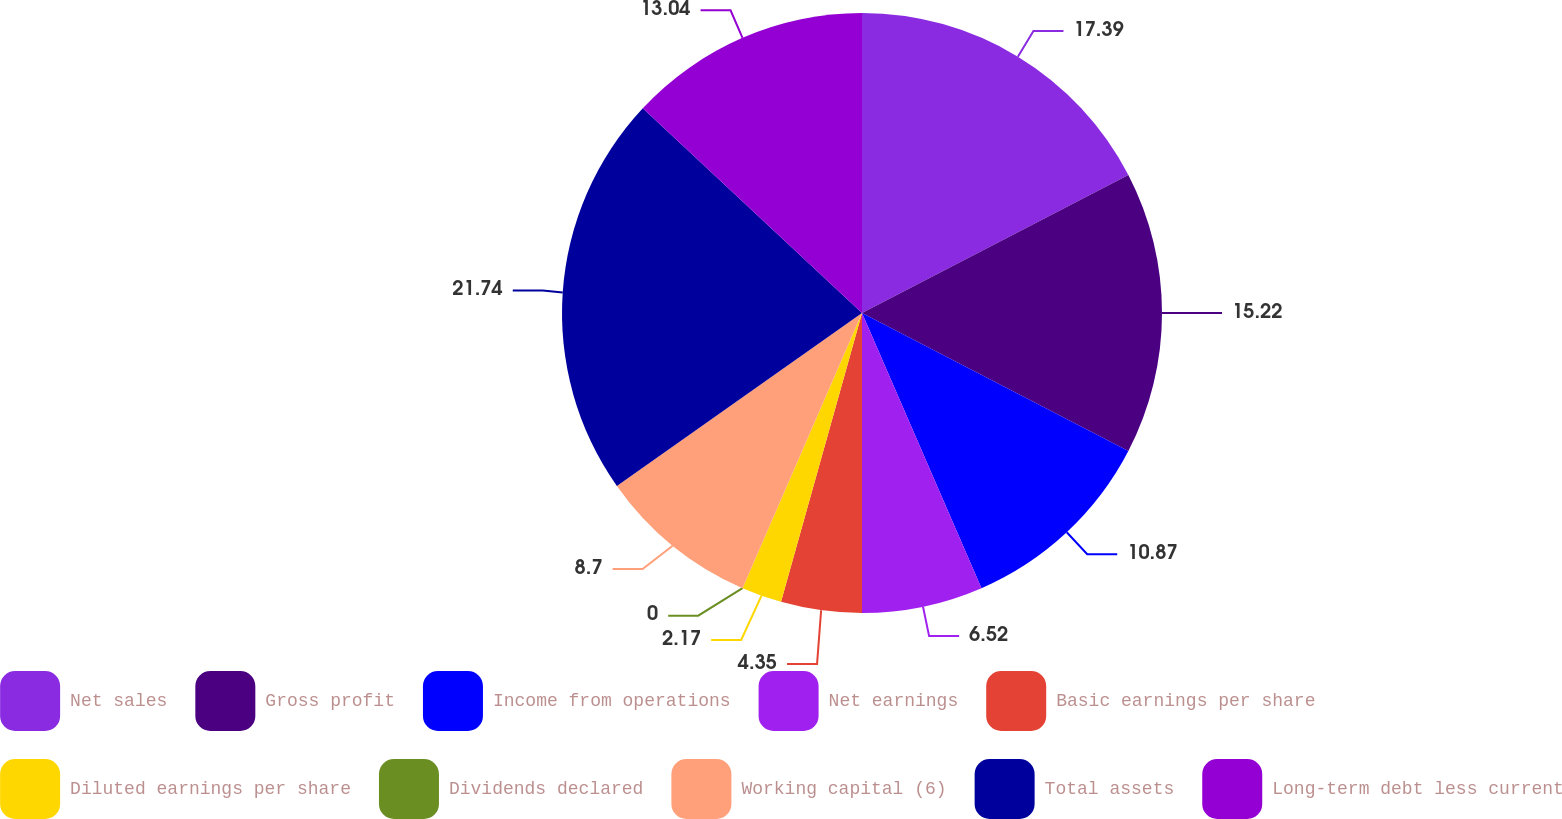Convert chart to OTSL. <chart><loc_0><loc_0><loc_500><loc_500><pie_chart><fcel>Net sales<fcel>Gross profit<fcel>Income from operations<fcel>Net earnings<fcel>Basic earnings per share<fcel>Diluted earnings per share<fcel>Dividends declared<fcel>Working capital (6)<fcel>Total assets<fcel>Long-term debt less current<nl><fcel>17.39%<fcel>15.22%<fcel>10.87%<fcel>6.52%<fcel>4.35%<fcel>2.17%<fcel>0.0%<fcel>8.7%<fcel>21.74%<fcel>13.04%<nl></chart> 